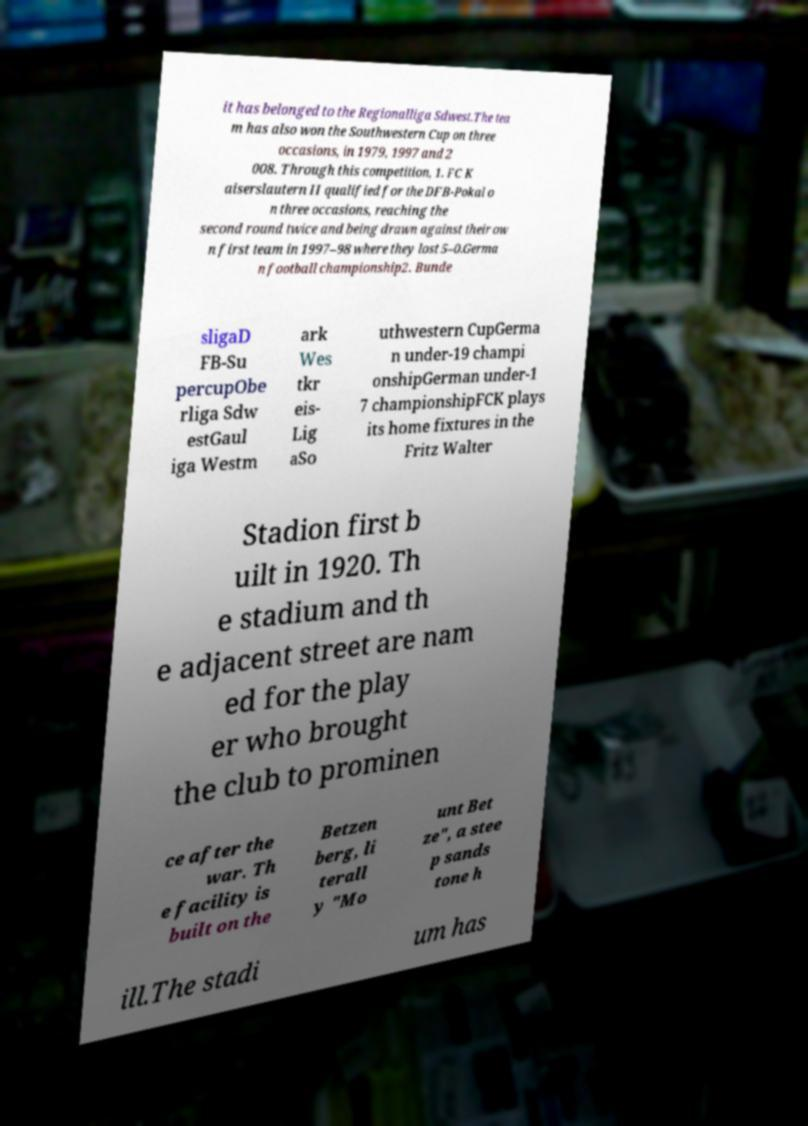Please identify and transcribe the text found in this image. it has belonged to the Regionalliga Sdwest.The tea m has also won the Southwestern Cup on three occasions, in 1979, 1997 and 2 008. Through this competition, 1. FC K aiserslautern II qualified for the DFB-Pokal o n three occasions, reaching the second round twice and being drawn against their ow n first team in 1997–98 where they lost 5–0.Germa n football championship2. Bunde sligaD FB-Su percupObe rliga Sdw estGaul iga Westm ark Wes tkr eis- Lig aSo uthwestern CupGerma n under-19 champi onshipGerman under-1 7 championshipFCK plays its home fixtures in the Fritz Walter Stadion first b uilt in 1920. Th e stadium and th e adjacent street are nam ed for the play er who brought the club to prominen ce after the war. Th e facility is built on the Betzen berg, li terall y "Mo unt Bet ze", a stee p sands tone h ill.The stadi um has 